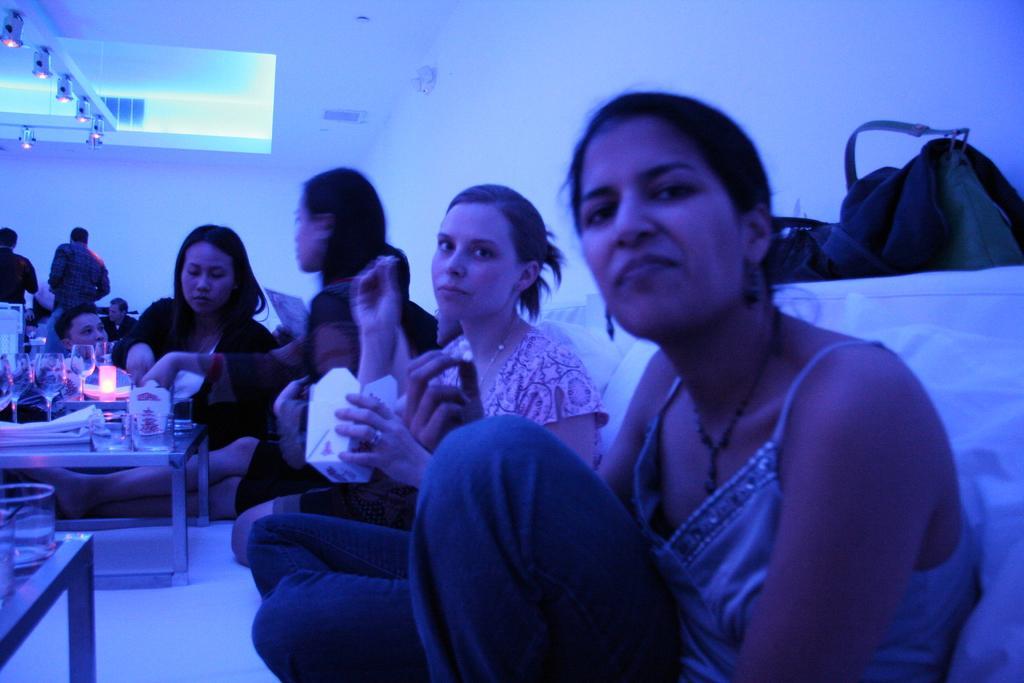Could you give a brief overview of what you see in this image? In the image there are girls sat on sofa and in front of them there is a small table with food and glasses on it and over the ceiling there are lights. 